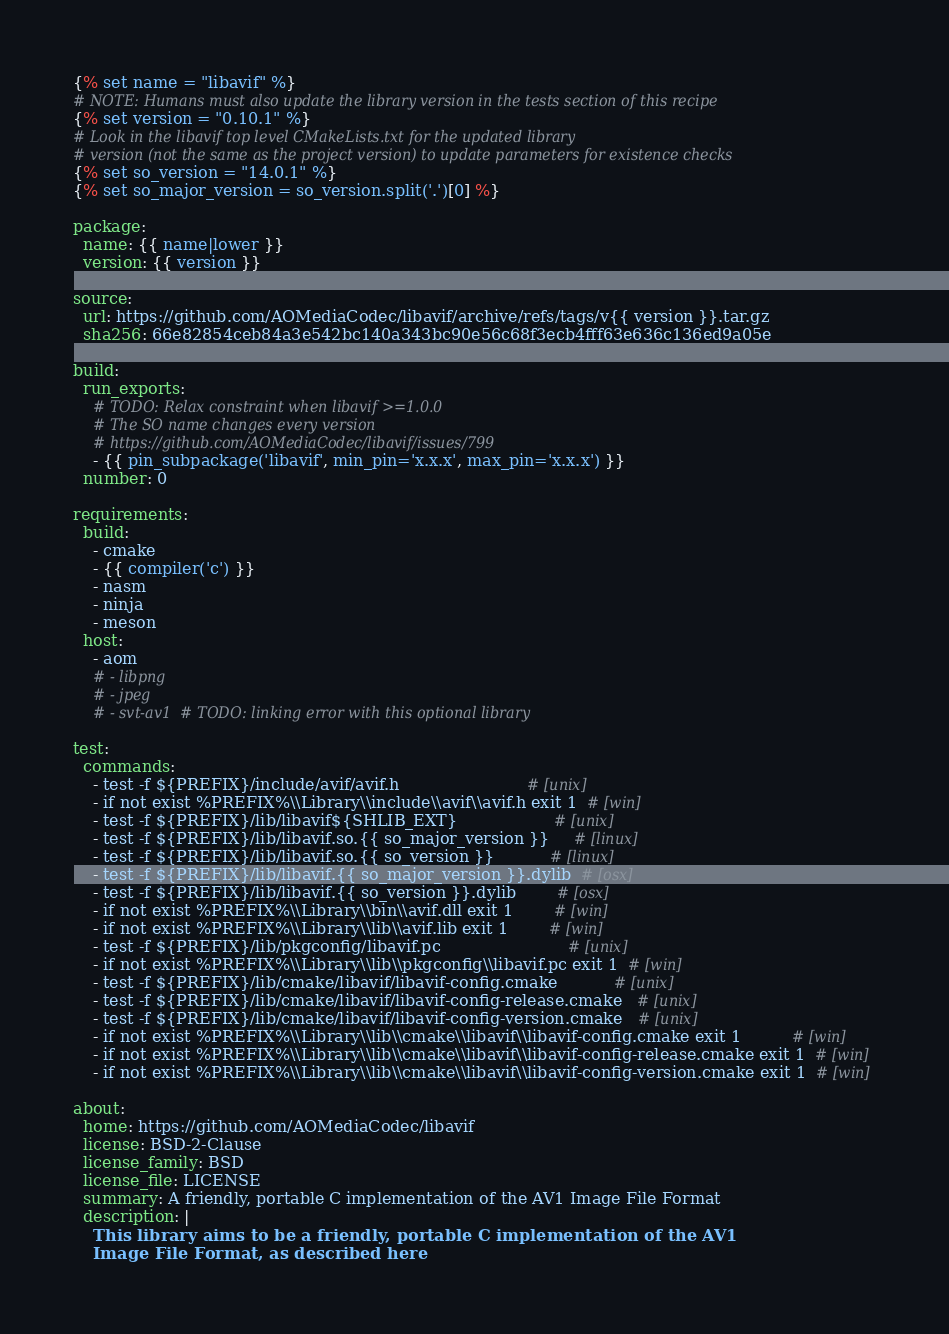Convert code to text. <code><loc_0><loc_0><loc_500><loc_500><_YAML_>{% set name = "libavif" %}
# NOTE: Humans must also update the library version in the tests section of this recipe
{% set version = "0.10.1" %}
# Look in the libavif top level CMakeLists.txt for the updated library
# version (not the same as the project version) to update parameters for existence checks
{% set so_version = "14.0.1" %}
{% set so_major_version = so_version.split('.')[0] %}

package:
  name: {{ name|lower }}
  version: {{ version }}

source:
  url: https://github.com/AOMediaCodec/libavif/archive/refs/tags/v{{ version }}.tar.gz
  sha256: 66e82854ceb84a3e542bc140a343bc90e56c68f3ecb4fff63e636c136ed9a05e

build:
  run_exports:
    # TODO: Relax constraint when libavif >=1.0.0
    # The SO name changes every version
    # https://github.com/AOMediaCodec/libavif/issues/799
    - {{ pin_subpackage('libavif', min_pin='x.x.x', max_pin='x.x.x') }}
  number: 0

requirements:
  build:
    - cmake
    - {{ compiler('c') }}
    - nasm
    - ninja
    - meson
  host:
    - aom
    # - libpng
    # - jpeg
    # - svt-av1  # TODO: linking error with this optional library

test:
  commands:
    - test -f ${PREFIX}/include/avif/avif.h                         # [unix]
    - if not exist %PREFIX%\\Library\\include\\avif\\avif.h exit 1  # [win]
    - test -f ${PREFIX}/lib/libavif${SHLIB_EXT}                   # [unix]
    - test -f ${PREFIX}/lib/libavif.so.{{ so_major_version }}     # [linux]
    - test -f ${PREFIX}/lib/libavif.so.{{ so_version }}           # [linux]
    - test -f ${PREFIX}/lib/libavif.{{ so_major_version }}.dylib  # [osx]
    - test -f ${PREFIX}/lib/libavif.{{ so_version }}.dylib        # [osx]
    - if not exist %PREFIX%\\Library\\bin\\avif.dll exit 1        # [win]
    - if not exist %PREFIX%\\Library\\lib\\avif.lib exit 1        # [win]
    - test -f ${PREFIX}/lib/pkgconfig/libavif.pc                         # [unix]
    - if not exist %PREFIX%\\Library\\lib\\pkgconfig\\libavif.pc exit 1  # [win]
    - test -f ${PREFIX}/lib/cmake/libavif/libavif-config.cmake           # [unix]
    - test -f ${PREFIX}/lib/cmake/libavif/libavif-config-release.cmake   # [unix]
    - test -f ${PREFIX}/lib/cmake/libavif/libavif-config-version.cmake   # [unix]
    - if not exist %PREFIX%\\Library\\lib\\cmake\\libavif\\libavif-config.cmake exit 1          # [win]
    - if not exist %PREFIX%\\Library\\lib\\cmake\\libavif\\libavif-config-release.cmake exit 1  # [win]
    - if not exist %PREFIX%\\Library\\lib\\cmake\\libavif\\libavif-config-version.cmake exit 1  # [win]

about:
  home: https://github.com/AOMediaCodec/libavif
  license: BSD-2-Clause
  license_family: BSD
  license_file: LICENSE
  summary: A friendly, portable C implementation of the AV1 Image File Format
  description: |
    This library aims to be a friendly, portable C implementation of the AV1
    Image File Format, as described here</code> 